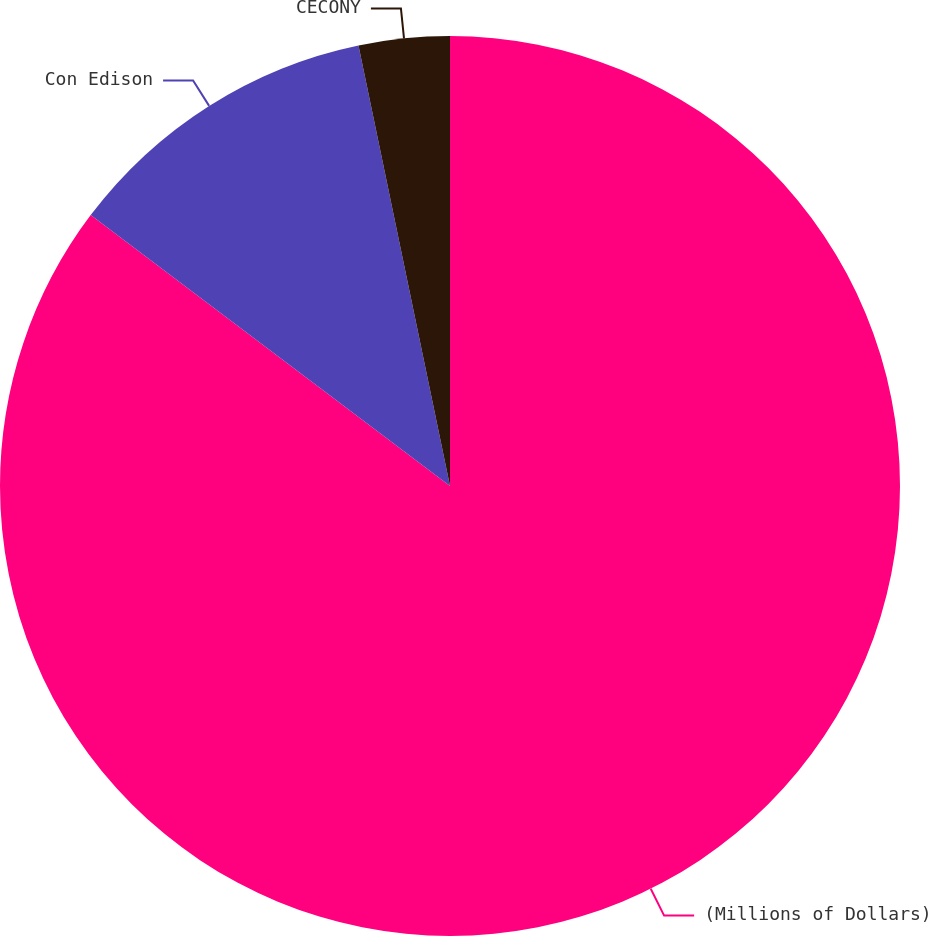<chart> <loc_0><loc_0><loc_500><loc_500><pie_chart><fcel>(Millions of Dollars)<fcel>Con Edison<fcel>CECONY<nl><fcel>85.29%<fcel>11.46%<fcel>3.26%<nl></chart> 